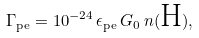<formula> <loc_0><loc_0><loc_500><loc_500>\Gamma _ { \text {pe} } = 1 0 ^ { - 2 4 } \, \epsilon _ { \text {pe} } \, G _ { 0 } \, n ( \text {H} ) ,</formula> 